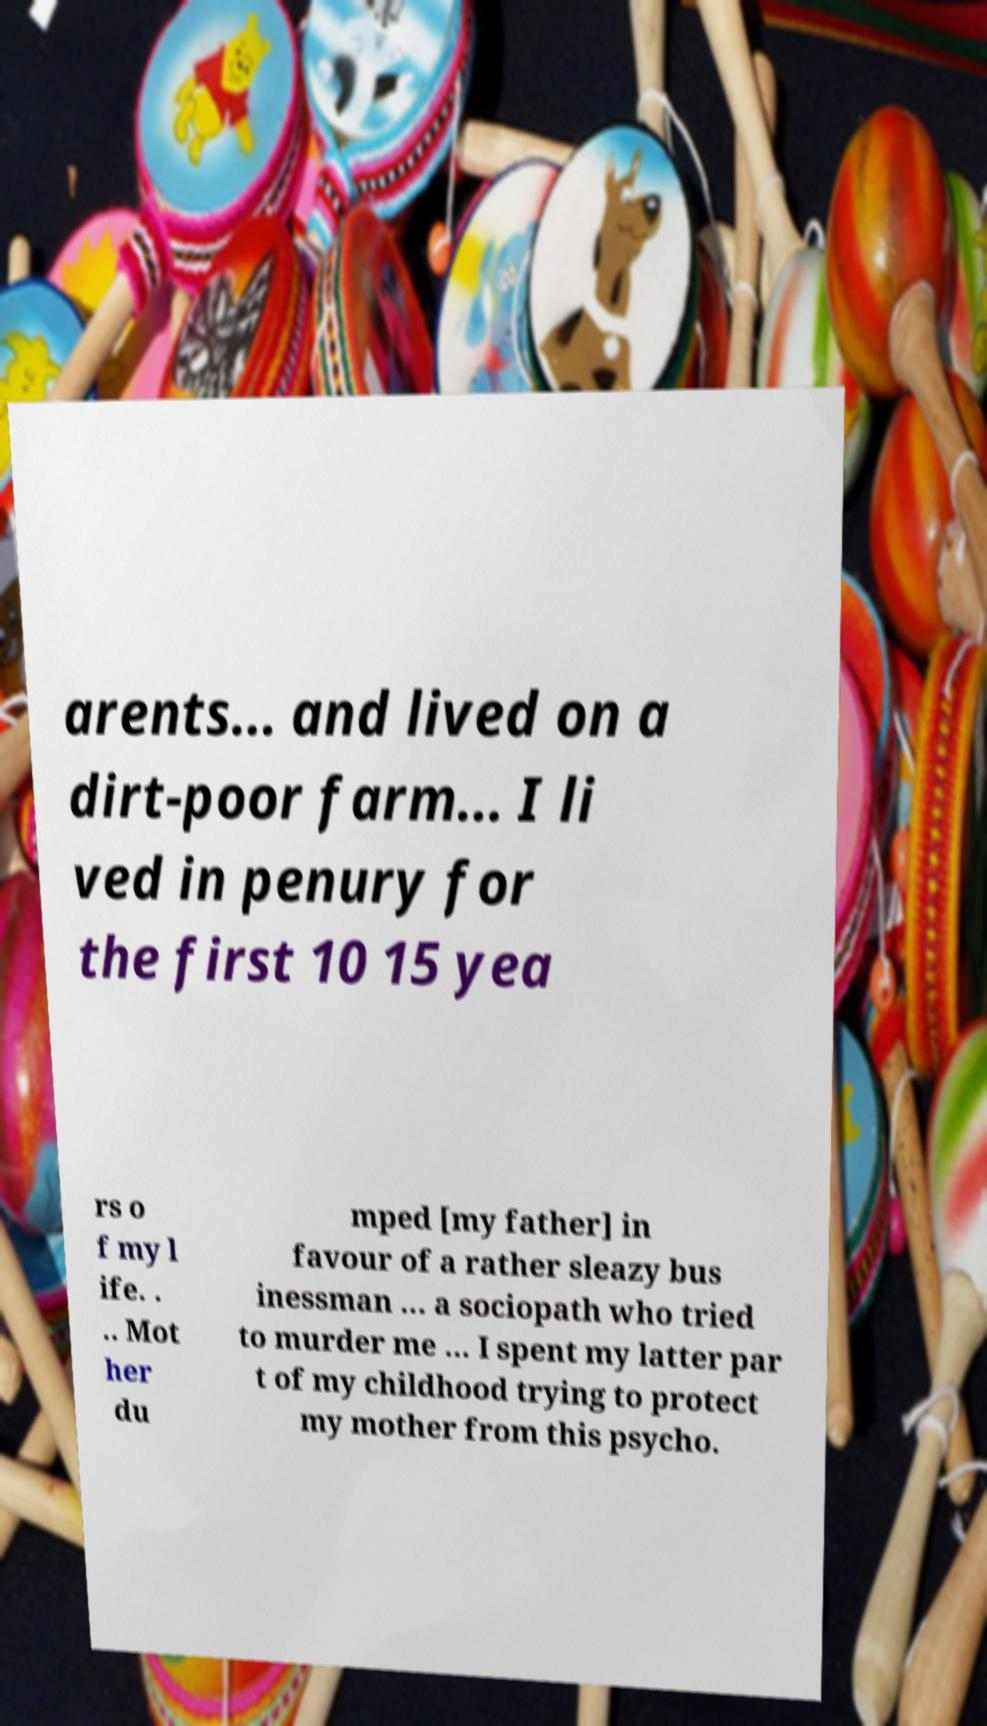I need the written content from this picture converted into text. Can you do that? arents... and lived on a dirt-poor farm... I li ved in penury for the first 10 15 yea rs o f my l ife. . .. Mot her du mped [my father] in favour of a rather sleazy bus inessman ... a sociopath who tried to murder me ... I spent my latter par t of my childhood trying to protect my mother from this psycho. 